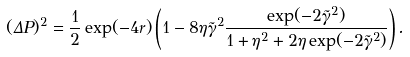Convert formula to latex. <formula><loc_0><loc_0><loc_500><loc_500>( \Delta P ) ^ { 2 } = \frac { 1 } { 2 } \exp ( - 4 r ) \left ( 1 - 8 \eta \tilde { \gamma } ^ { 2 } \frac { \exp ( - 2 \tilde { \gamma } ^ { 2 } ) } { 1 + \eta ^ { 2 } + 2 \eta \exp ( - 2 \tilde { \gamma } ^ { 2 } ) } \right ) .</formula> 